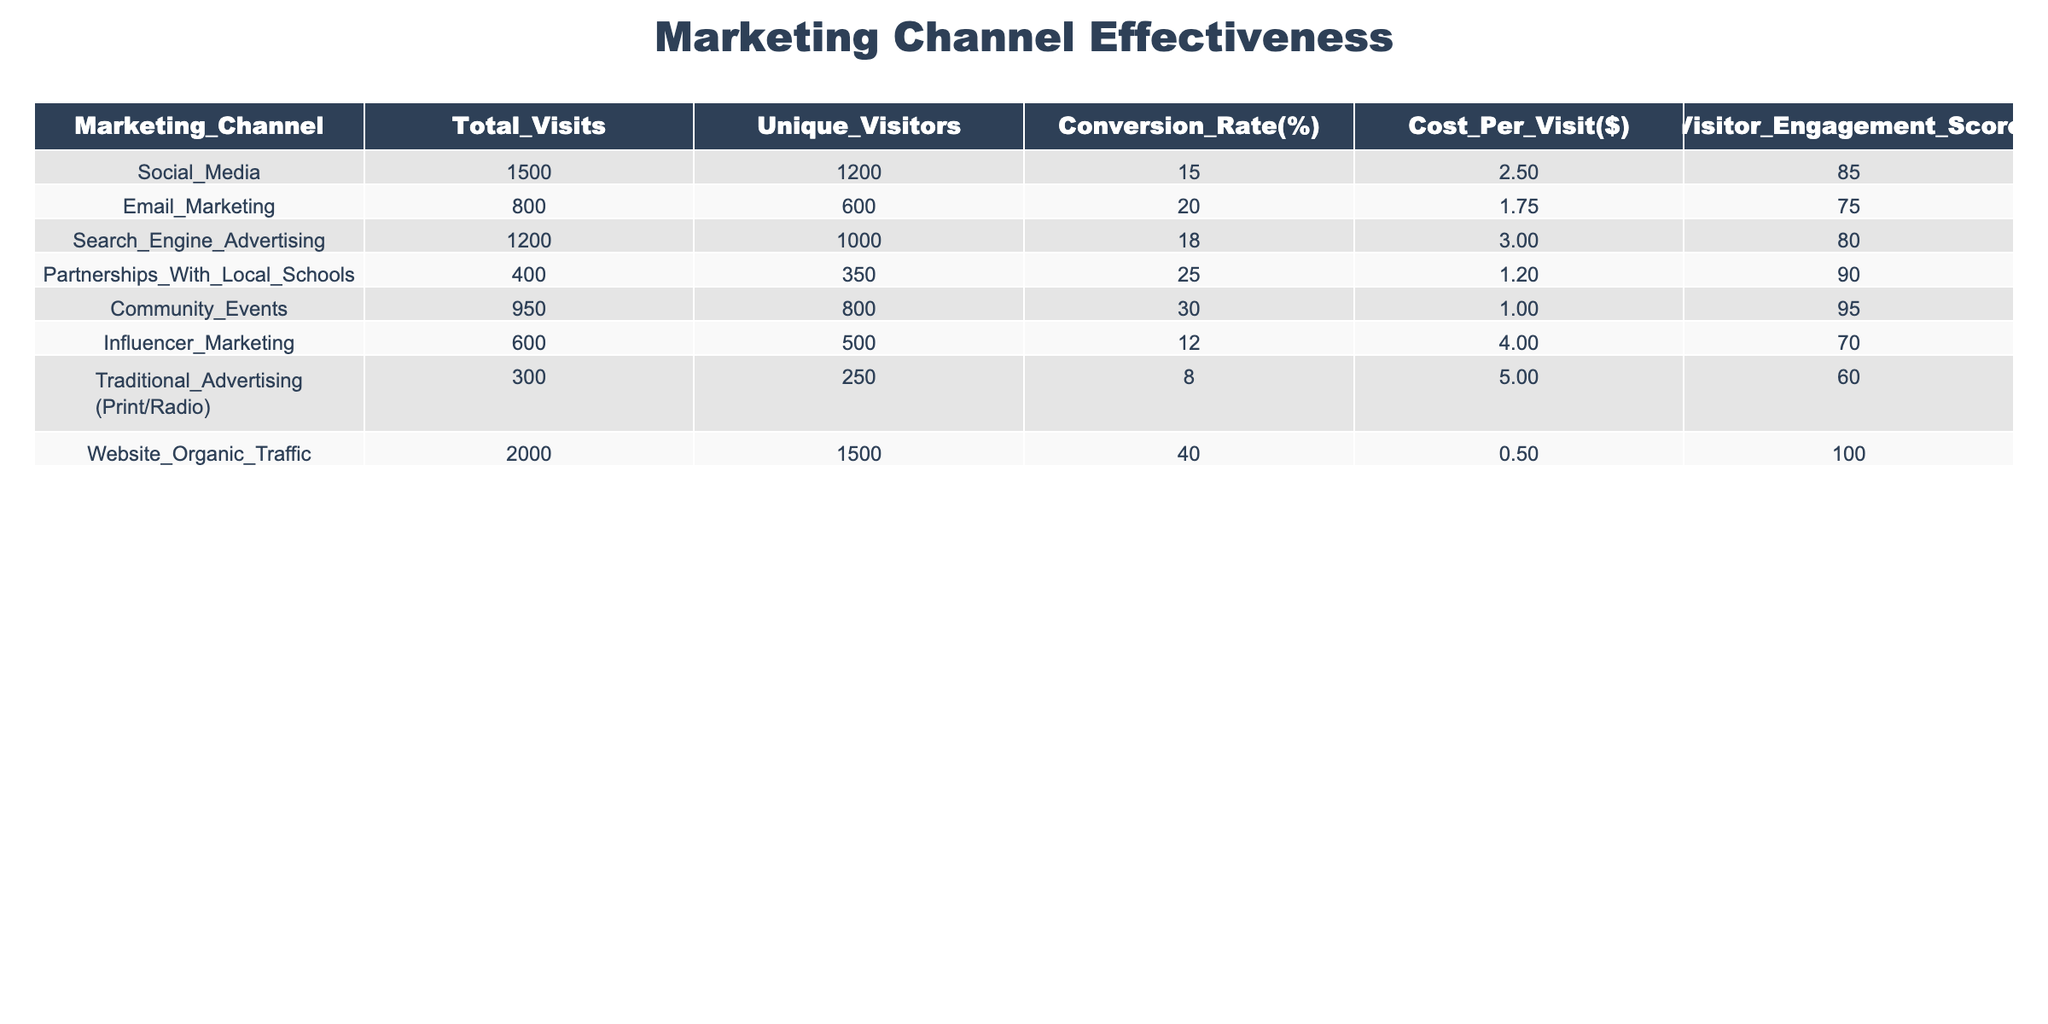What is the conversion rate for Community Events? The table shows a specific column for Conversion Rate (%). For Community Events, this rate is listed as 30%.
Answer: 30% Which marketing channel generated the most unique visitors? The Unique Visitors column indicates that Website Organic Traffic has the highest number at 1500.
Answer: 1500 What is the average cost per visit across all marketing channels? To find the average, sum the Cost Per Visit values: (2.50 + 1.75 + 3.00 + 1.20 + 1.00 + 4.00 + 5.00 + 0.50) = 19.95. There are 8 channels, so divide: 19.95 / 8 = 2.49.
Answer: 2.49 Is the Conversion Rate for Partnerships With Local Schools higher than that for Influencer Marketing? The Conversion Rate for Partnerships With Local Schools is 25%, while Influencer Marketing has a rate of 12%. Since 25% is greater than 12%, the answer is yes.
Answer: Yes What is the total number of visits from all marketing channels combined? Add all the Total Visits: 1500 + 800 + 1200 + 400 + 950 + 600 + 300 + 2000 = 6750.
Answer: 6750 Which marketing channel has the lowest Visitor Engagement Score? By looking at the Visitor Engagement Score column, Traditional Advertising (Print/Radio) has the lowest score of 60.
Answer: 60 If I combine the visitors from Email Marketing and Influencer Marketing, is it more than the visitors from Community Events? Email Marketing has 600 visitors and Influencer Marketing has 500, summing to 600 + 500 = 1100. Community Events has 800 visitors. Since 1100 is greater than 800, the answer is yes.
Answer: Yes What is the difference in Total Visits between Website Organic Traffic and Traditional Advertising? The Total Visits for Website Organic Traffic is 2000, while Traditional Advertising has 300. The difference is 2000 - 300 = 1700.
Answer: 1700 Which channel has the highest Visitor Engagement Score and what is its score? The highest Engagement Score is found in Website Organic Traffic, with a score of 100.
Answer: 100 Are more unique visitors attracted through Community Events or Search Engine Advertising? Community Events have 800 unique visitors, while Search Engine Advertising has 1000 unique visitors. Since 1000 is greater than 800, more unique visitors come from Search Engine Advertising.
Answer: Search Engine Advertising 